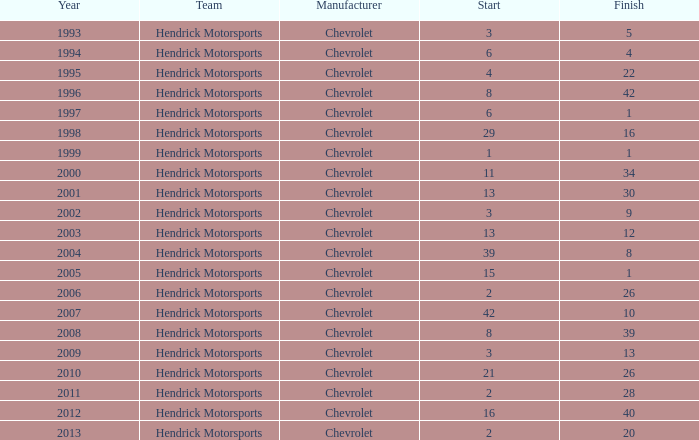What was Jeff's finish in 2011? 28.0. 